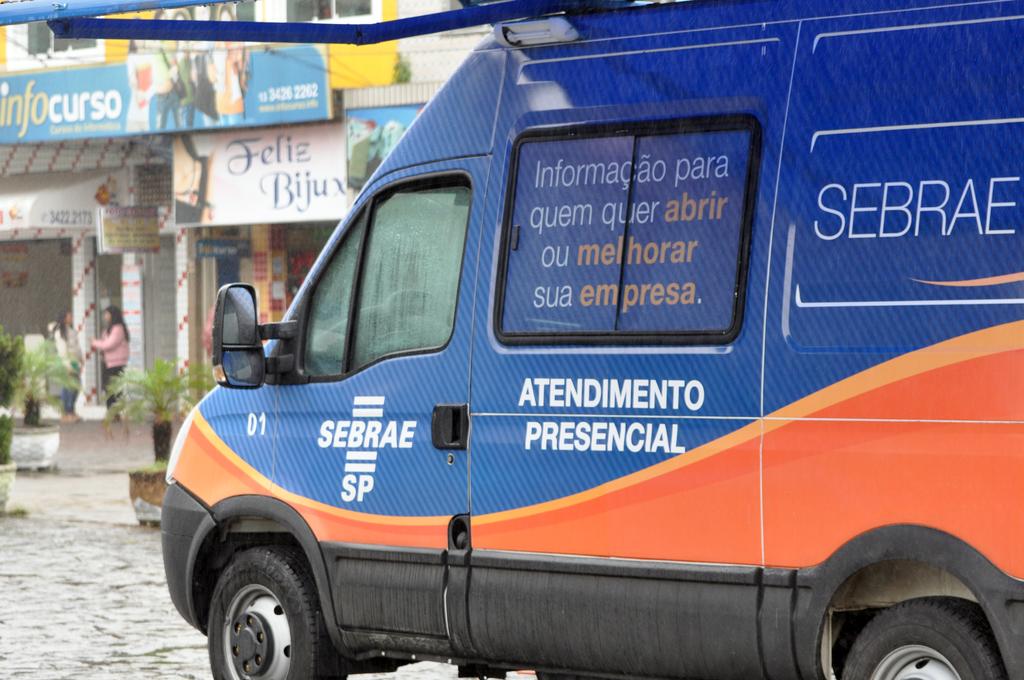What is the company's name on this van?
Give a very brief answer. Sebrae. What language is the text on the van?
Keep it short and to the point. Unanswerable. 